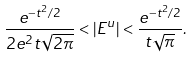Convert formula to latex. <formula><loc_0><loc_0><loc_500><loc_500>\frac { e ^ { - t ^ { 2 } / 2 } } { 2 e ^ { 2 } t \sqrt { 2 \pi } } < | E ^ { u } | < \frac { e ^ { - t ^ { 2 } / 2 } } { t \sqrt { \pi } } .</formula> 